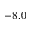Convert formula to latex. <formula><loc_0><loc_0><loc_500><loc_500>- 8 . 0</formula> 